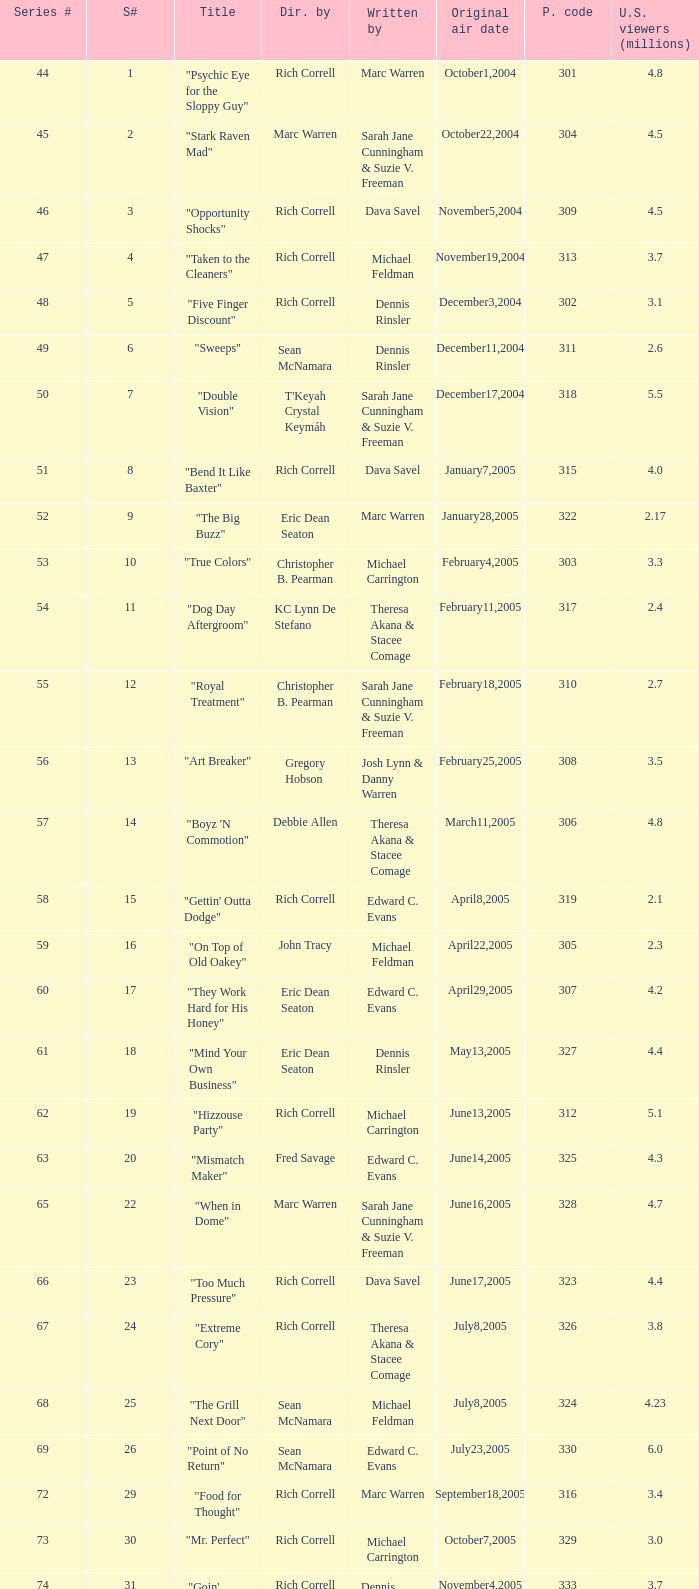What was the production code of the episode directed by Rondell Sheridan?  332.0. 